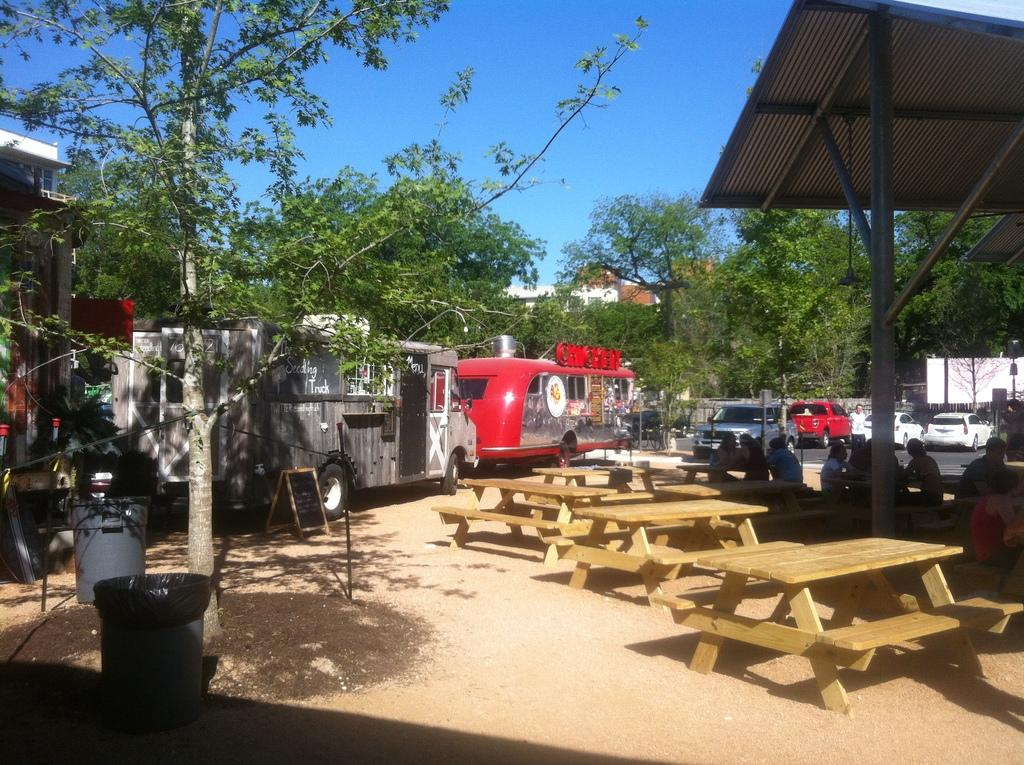What are the people in the image doing? The people in the image are sitting on a bench. What other object is present in the image besides the bench? There is a table in the image. What can be seen in the background of the image? Vehicles, trees, and a bin are visible in the background of the image. What type of book is the person reading on the bench? There is no book present in the image; the people are simply sitting on the bench. 